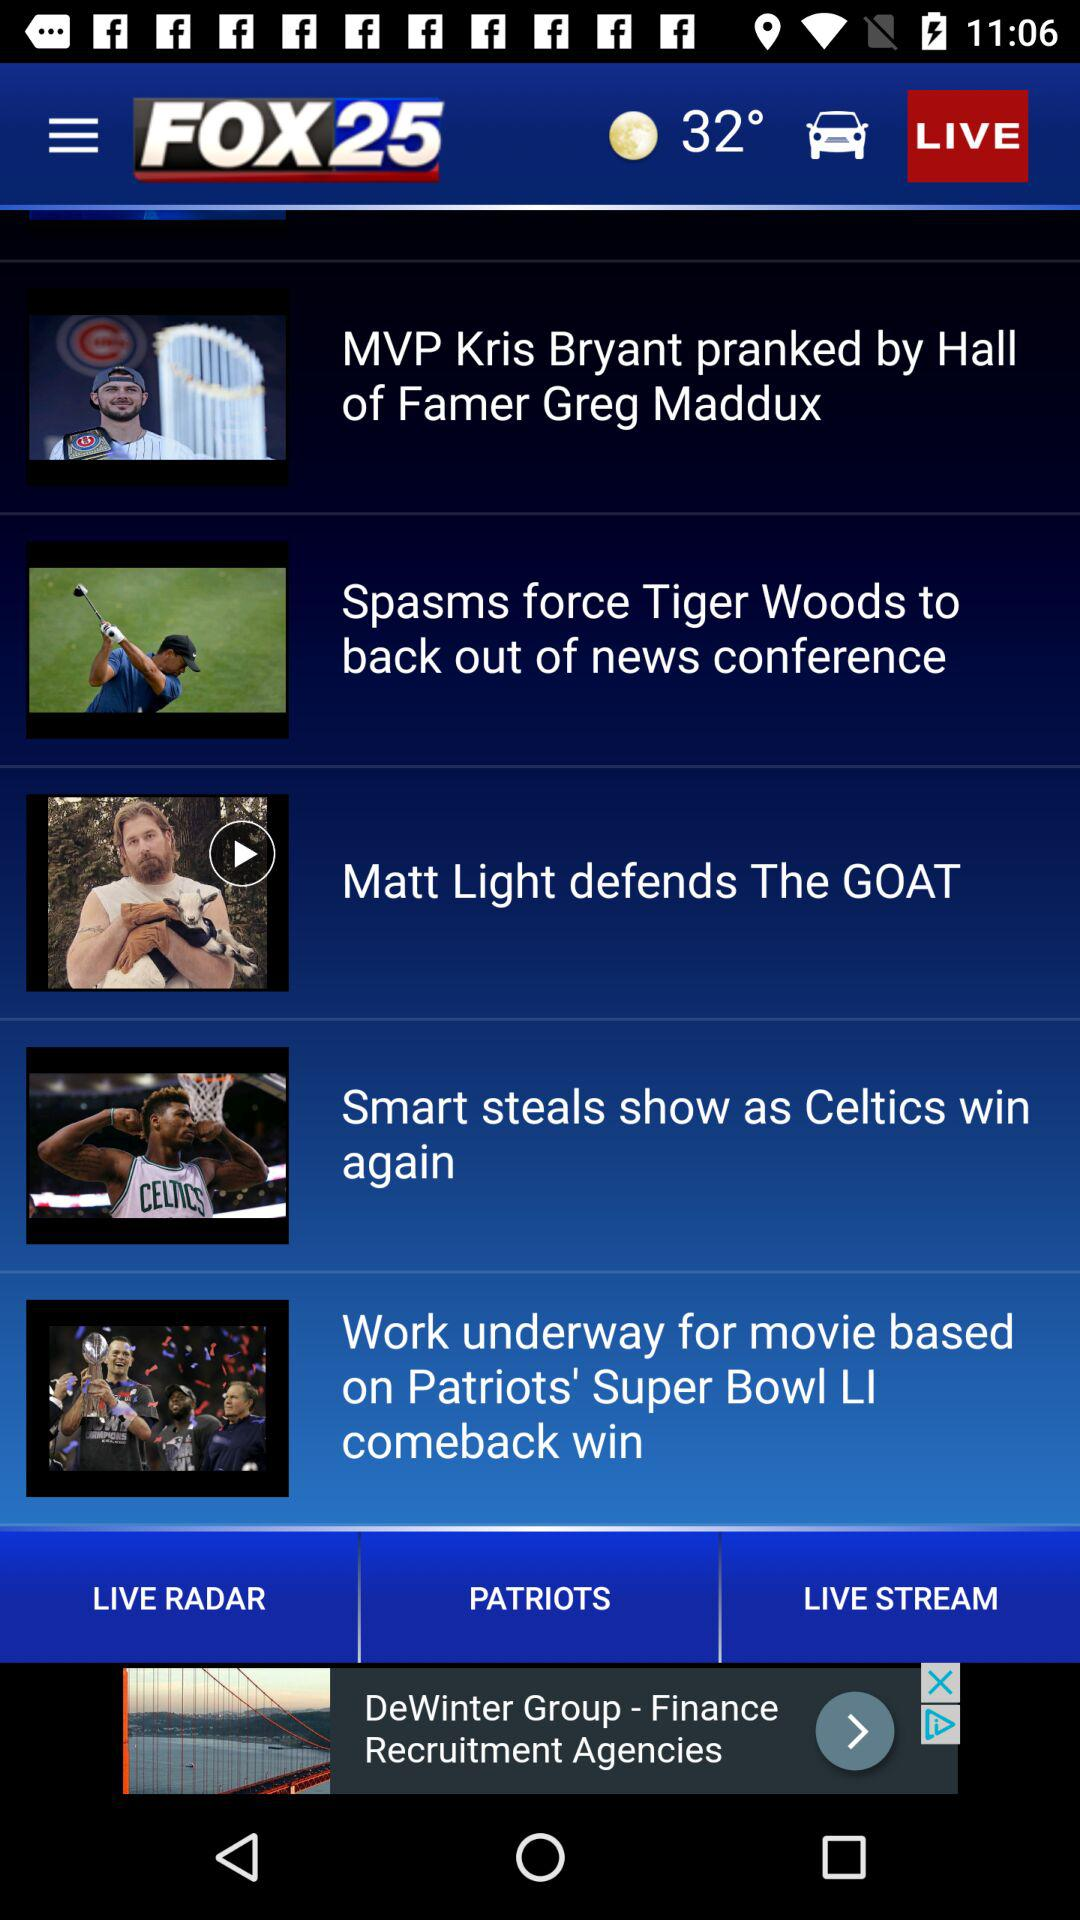What's the temperature? The temperature is 32 degrees. 